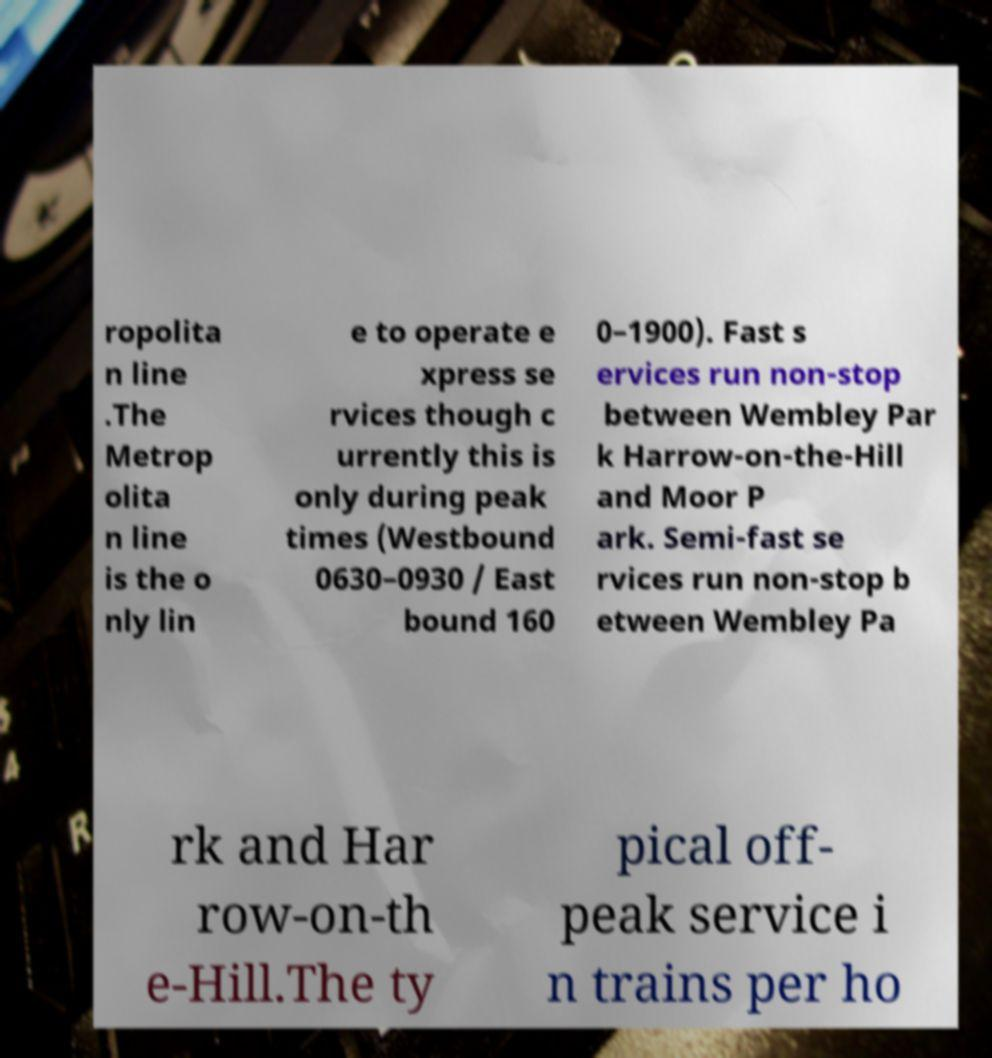Can you accurately transcribe the text from the provided image for me? ropolita n line .The Metrop olita n line is the o nly lin e to operate e xpress se rvices though c urrently this is only during peak times (Westbound 0630–0930 / East bound 160 0–1900). Fast s ervices run non-stop between Wembley Par k Harrow-on-the-Hill and Moor P ark. Semi-fast se rvices run non-stop b etween Wembley Pa rk and Har row-on-th e-Hill.The ty pical off- peak service i n trains per ho 